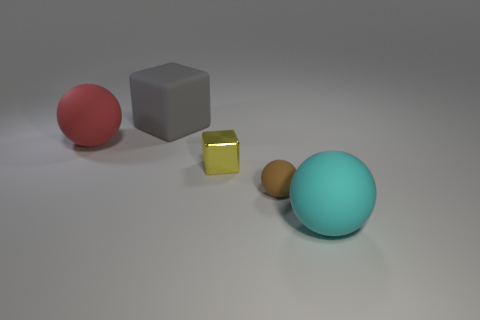What material is the tiny yellow cube?
Give a very brief answer. Metal. What color is the metal cube that is the same size as the brown rubber ball?
Keep it short and to the point. Yellow. Is the shape of the large red object the same as the tiny metallic object?
Make the answer very short. No. The thing that is on the left side of the small rubber object and in front of the large red matte object is made of what material?
Your answer should be very brief. Metal. What is the size of the cyan ball?
Your answer should be compact. Large. There is another large rubber thing that is the same shape as the cyan matte object; what is its color?
Provide a short and direct response. Red. There is a matte ball on the left side of the big gray matte cube; is it the same size as the object behind the large red rubber object?
Your response must be concise. Yes. Is the number of large matte balls that are to the left of the cyan ball the same as the number of tiny things to the right of the brown object?
Provide a short and direct response. No. Does the yellow thing have the same size as the brown matte object to the right of the large gray rubber cube?
Offer a terse response. Yes. There is a large ball that is left of the gray rubber block; are there any gray matte cubes behind it?
Your answer should be very brief. Yes. 